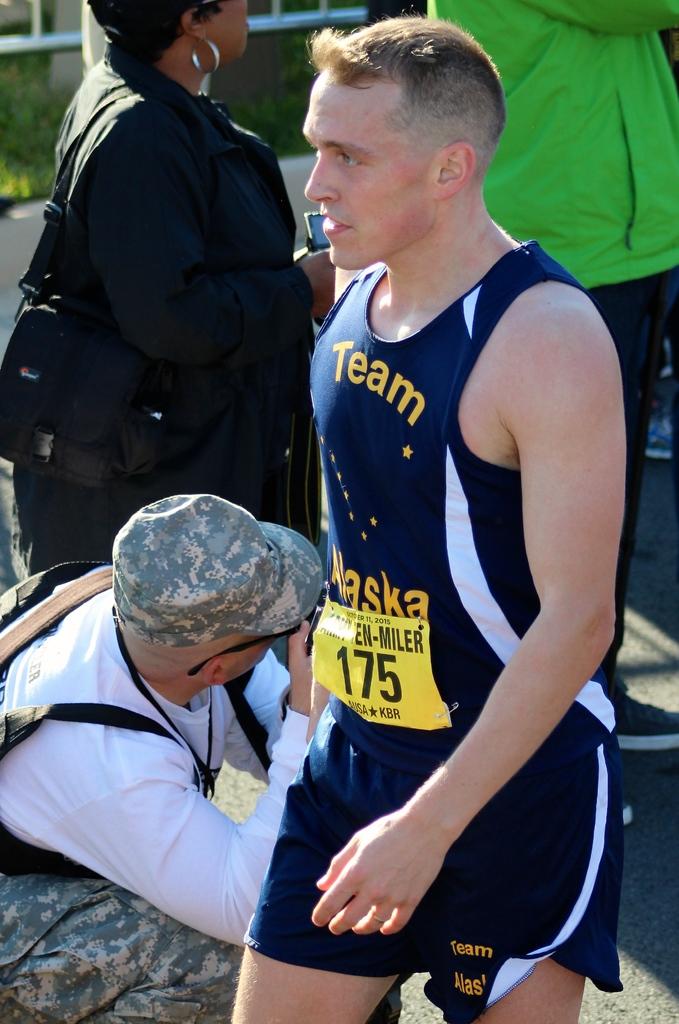What entrant number does the person in blue have?
Provide a short and direct response. 175. Is he a member of a team?
Keep it short and to the point. Yes. 